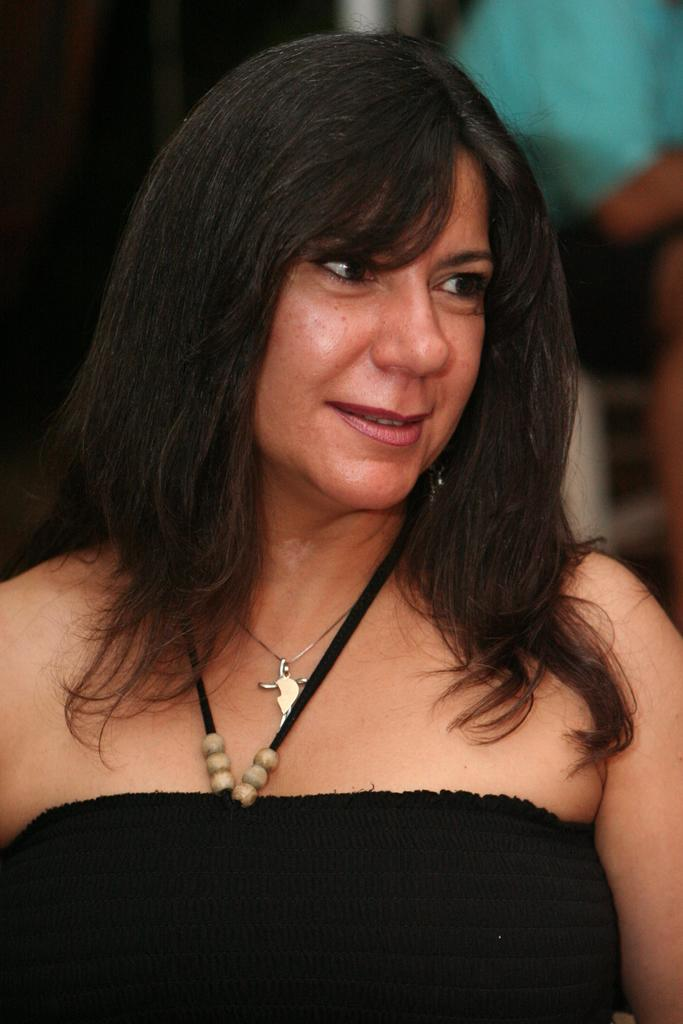What is the main subject of the image? The main subject of the image is a woman. What is the woman wearing in the image? The woman is wearing a black dress. Can you describe the background of the image? The background of the image is blurred. What is the amount of water visible in the image? There is no water present in the image. What type of whistle can be heard in the background of the image? There is no whistle sound present in the image, as it is a still photograph. 